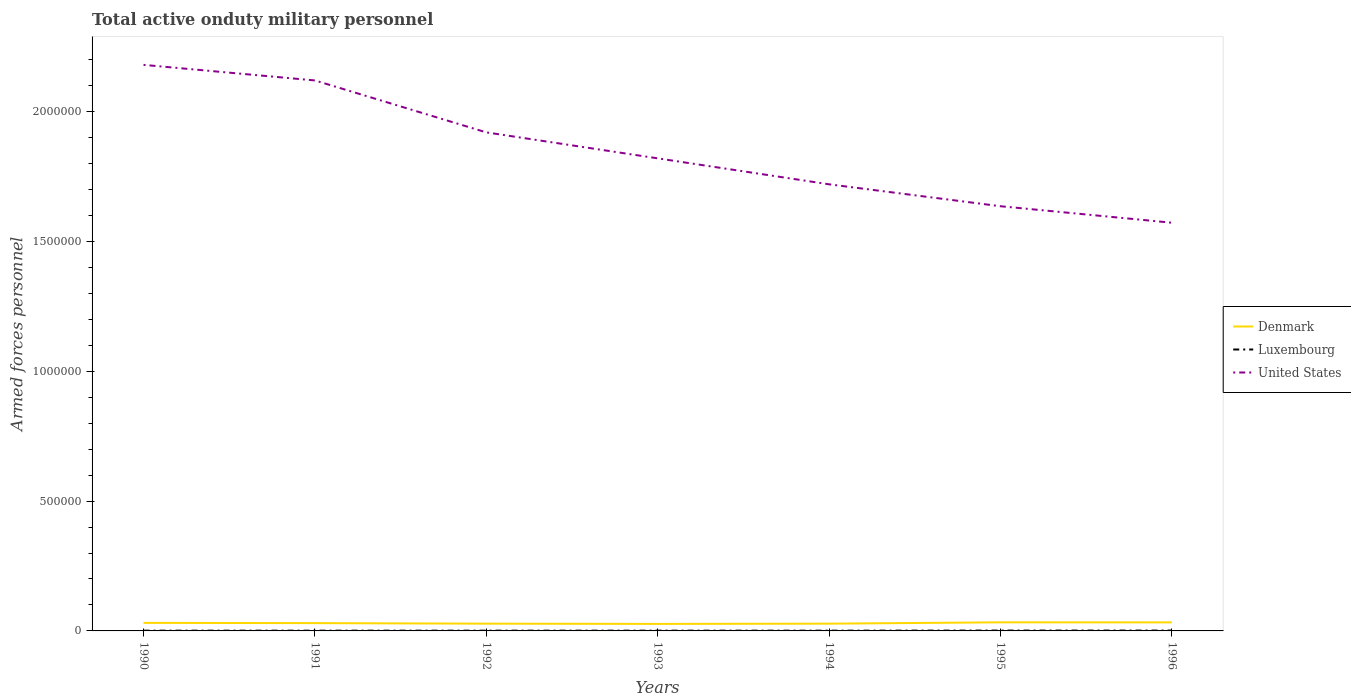Across all years, what is the maximum number of armed forces personnel in United States?
Your answer should be compact. 1.57e+06. What is the total number of armed forces personnel in United States in the graph?
Provide a short and direct response. 5.48e+05. What is the difference between the highest and the second highest number of armed forces personnel in Denmark?
Offer a very short reply. 6100. What is the difference between the highest and the lowest number of armed forces personnel in Luxembourg?
Make the answer very short. 2. Is the number of armed forces personnel in Denmark strictly greater than the number of armed forces personnel in United States over the years?
Keep it short and to the point. Yes. How many lines are there?
Offer a very short reply. 3. How many years are there in the graph?
Give a very brief answer. 7. What is the difference between two consecutive major ticks on the Y-axis?
Offer a very short reply. 5.00e+05. Are the values on the major ticks of Y-axis written in scientific E-notation?
Your answer should be compact. No. Does the graph contain any zero values?
Keep it short and to the point. No. How are the legend labels stacked?
Offer a terse response. Vertical. What is the title of the graph?
Your answer should be very brief. Total active onduty military personnel. Does "Malta" appear as one of the legend labels in the graph?
Your answer should be very brief. No. What is the label or title of the X-axis?
Provide a short and direct response. Years. What is the label or title of the Y-axis?
Offer a terse response. Armed forces personnel. What is the Armed forces personnel in Denmark in 1990?
Your answer should be compact. 3.10e+04. What is the Armed forces personnel in United States in 1990?
Offer a very short reply. 2.18e+06. What is the Armed forces personnel in Luxembourg in 1991?
Offer a terse response. 1000. What is the Armed forces personnel in United States in 1991?
Give a very brief answer. 2.12e+06. What is the Armed forces personnel of Denmark in 1992?
Provide a short and direct response. 2.80e+04. What is the Armed forces personnel in United States in 1992?
Keep it short and to the point. 1.92e+06. What is the Armed forces personnel in Denmark in 1993?
Your response must be concise. 2.70e+04. What is the Armed forces personnel in Luxembourg in 1993?
Offer a terse response. 1000. What is the Armed forces personnel in United States in 1993?
Make the answer very short. 1.82e+06. What is the Armed forces personnel of Denmark in 1994?
Provide a short and direct response. 2.80e+04. What is the Armed forces personnel of Luxembourg in 1994?
Make the answer very short. 1000. What is the Armed forces personnel in United States in 1994?
Your answer should be compact. 1.72e+06. What is the Armed forces personnel of Denmark in 1995?
Provide a short and direct response. 3.31e+04. What is the Armed forces personnel in Luxembourg in 1995?
Make the answer very short. 1400. What is the Armed forces personnel of United States in 1995?
Your answer should be very brief. 1.64e+06. What is the Armed forces personnel in Denmark in 1996?
Provide a succinct answer. 3.29e+04. What is the Armed forces personnel in Luxembourg in 1996?
Give a very brief answer. 1400. What is the Armed forces personnel in United States in 1996?
Make the answer very short. 1.57e+06. Across all years, what is the maximum Armed forces personnel of Denmark?
Offer a very short reply. 3.31e+04. Across all years, what is the maximum Armed forces personnel in Luxembourg?
Your answer should be compact. 1400. Across all years, what is the maximum Armed forces personnel of United States?
Provide a short and direct response. 2.18e+06. Across all years, what is the minimum Armed forces personnel in Denmark?
Your answer should be very brief. 2.70e+04. Across all years, what is the minimum Armed forces personnel of United States?
Provide a short and direct response. 1.57e+06. What is the total Armed forces personnel in Denmark in the graph?
Keep it short and to the point. 2.10e+05. What is the total Armed forces personnel of Luxembourg in the graph?
Ensure brevity in your answer.  7800. What is the total Armed forces personnel in United States in the graph?
Your answer should be compact. 1.30e+07. What is the difference between the Armed forces personnel in Denmark in 1990 and that in 1991?
Give a very brief answer. 1000. What is the difference between the Armed forces personnel of Luxembourg in 1990 and that in 1991?
Offer a very short reply. 0. What is the difference between the Armed forces personnel in United States in 1990 and that in 1991?
Give a very brief answer. 6.00e+04. What is the difference between the Armed forces personnel of Denmark in 1990 and that in 1992?
Keep it short and to the point. 3000. What is the difference between the Armed forces personnel in Luxembourg in 1990 and that in 1992?
Make the answer very short. 0. What is the difference between the Armed forces personnel of United States in 1990 and that in 1992?
Give a very brief answer. 2.60e+05. What is the difference between the Armed forces personnel of Denmark in 1990 and that in 1993?
Ensure brevity in your answer.  4000. What is the difference between the Armed forces personnel of Luxembourg in 1990 and that in 1993?
Provide a short and direct response. 0. What is the difference between the Armed forces personnel in United States in 1990 and that in 1993?
Give a very brief answer. 3.60e+05. What is the difference between the Armed forces personnel in Denmark in 1990 and that in 1994?
Ensure brevity in your answer.  3000. What is the difference between the Armed forces personnel of Denmark in 1990 and that in 1995?
Ensure brevity in your answer.  -2100. What is the difference between the Armed forces personnel of Luxembourg in 1990 and that in 1995?
Provide a succinct answer. -400. What is the difference between the Armed forces personnel of United States in 1990 and that in 1995?
Provide a succinct answer. 5.44e+05. What is the difference between the Armed forces personnel in Denmark in 1990 and that in 1996?
Offer a terse response. -1900. What is the difference between the Armed forces personnel of Luxembourg in 1990 and that in 1996?
Offer a very short reply. -400. What is the difference between the Armed forces personnel of United States in 1990 and that in 1996?
Your answer should be compact. 6.08e+05. What is the difference between the Armed forces personnel in Denmark in 1991 and that in 1992?
Your answer should be compact. 2000. What is the difference between the Armed forces personnel in United States in 1991 and that in 1992?
Offer a terse response. 2.00e+05. What is the difference between the Armed forces personnel of Denmark in 1991 and that in 1993?
Your answer should be compact. 3000. What is the difference between the Armed forces personnel in United States in 1991 and that in 1993?
Offer a terse response. 3.00e+05. What is the difference between the Armed forces personnel in Denmark in 1991 and that in 1994?
Give a very brief answer. 2000. What is the difference between the Armed forces personnel of Luxembourg in 1991 and that in 1994?
Provide a succinct answer. 0. What is the difference between the Armed forces personnel in United States in 1991 and that in 1994?
Keep it short and to the point. 4.00e+05. What is the difference between the Armed forces personnel in Denmark in 1991 and that in 1995?
Keep it short and to the point. -3100. What is the difference between the Armed forces personnel in Luxembourg in 1991 and that in 1995?
Keep it short and to the point. -400. What is the difference between the Armed forces personnel of United States in 1991 and that in 1995?
Provide a succinct answer. 4.84e+05. What is the difference between the Armed forces personnel in Denmark in 1991 and that in 1996?
Ensure brevity in your answer.  -2900. What is the difference between the Armed forces personnel of Luxembourg in 1991 and that in 1996?
Keep it short and to the point. -400. What is the difference between the Armed forces personnel in United States in 1991 and that in 1996?
Keep it short and to the point. 5.48e+05. What is the difference between the Armed forces personnel in Luxembourg in 1992 and that in 1993?
Your answer should be compact. 0. What is the difference between the Armed forces personnel in United States in 1992 and that in 1993?
Offer a very short reply. 1.00e+05. What is the difference between the Armed forces personnel of Denmark in 1992 and that in 1994?
Your answer should be very brief. 0. What is the difference between the Armed forces personnel of United States in 1992 and that in 1994?
Your answer should be very brief. 2.00e+05. What is the difference between the Armed forces personnel in Denmark in 1992 and that in 1995?
Make the answer very short. -5100. What is the difference between the Armed forces personnel of Luxembourg in 1992 and that in 1995?
Make the answer very short. -400. What is the difference between the Armed forces personnel of United States in 1992 and that in 1995?
Your response must be concise. 2.84e+05. What is the difference between the Armed forces personnel in Denmark in 1992 and that in 1996?
Make the answer very short. -4900. What is the difference between the Armed forces personnel in Luxembourg in 1992 and that in 1996?
Your answer should be compact. -400. What is the difference between the Armed forces personnel of United States in 1992 and that in 1996?
Make the answer very short. 3.48e+05. What is the difference between the Armed forces personnel in Denmark in 1993 and that in 1994?
Offer a terse response. -1000. What is the difference between the Armed forces personnel of Luxembourg in 1993 and that in 1994?
Provide a succinct answer. 0. What is the difference between the Armed forces personnel of Denmark in 1993 and that in 1995?
Ensure brevity in your answer.  -6100. What is the difference between the Armed forces personnel in Luxembourg in 1993 and that in 1995?
Offer a very short reply. -400. What is the difference between the Armed forces personnel in United States in 1993 and that in 1995?
Your response must be concise. 1.84e+05. What is the difference between the Armed forces personnel in Denmark in 1993 and that in 1996?
Provide a succinct answer. -5900. What is the difference between the Armed forces personnel of Luxembourg in 1993 and that in 1996?
Your response must be concise. -400. What is the difference between the Armed forces personnel of United States in 1993 and that in 1996?
Provide a short and direct response. 2.48e+05. What is the difference between the Armed forces personnel of Denmark in 1994 and that in 1995?
Provide a succinct answer. -5100. What is the difference between the Armed forces personnel of Luxembourg in 1994 and that in 1995?
Offer a terse response. -400. What is the difference between the Armed forces personnel of United States in 1994 and that in 1995?
Offer a very short reply. 8.44e+04. What is the difference between the Armed forces personnel in Denmark in 1994 and that in 1996?
Give a very brief answer. -4900. What is the difference between the Armed forces personnel in Luxembourg in 1994 and that in 1996?
Your answer should be very brief. -400. What is the difference between the Armed forces personnel of United States in 1994 and that in 1996?
Your answer should be compact. 1.48e+05. What is the difference between the Armed forces personnel in United States in 1995 and that in 1996?
Make the answer very short. 6.35e+04. What is the difference between the Armed forces personnel in Denmark in 1990 and the Armed forces personnel in Luxembourg in 1991?
Keep it short and to the point. 3.00e+04. What is the difference between the Armed forces personnel in Denmark in 1990 and the Armed forces personnel in United States in 1991?
Keep it short and to the point. -2.09e+06. What is the difference between the Armed forces personnel in Luxembourg in 1990 and the Armed forces personnel in United States in 1991?
Ensure brevity in your answer.  -2.12e+06. What is the difference between the Armed forces personnel in Denmark in 1990 and the Armed forces personnel in United States in 1992?
Make the answer very short. -1.89e+06. What is the difference between the Armed forces personnel in Luxembourg in 1990 and the Armed forces personnel in United States in 1992?
Offer a terse response. -1.92e+06. What is the difference between the Armed forces personnel of Denmark in 1990 and the Armed forces personnel of United States in 1993?
Ensure brevity in your answer.  -1.79e+06. What is the difference between the Armed forces personnel in Luxembourg in 1990 and the Armed forces personnel in United States in 1993?
Keep it short and to the point. -1.82e+06. What is the difference between the Armed forces personnel of Denmark in 1990 and the Armed forces personnel of Luxembourg in 1994?
Your response must be concise. 3.00e+04. What is the difference between the Armed forces personnel of Denmark in 1990 and the Armed forces personnel of United States in 1994?
Your answer should be compact. -1.69e+06. What is the difference between the Armed forces personnel of Luxembourg in 1990 and the Armed forces personnel of United States in 1994?
Give a very brief answer. -1.72e+06. What is the difference between the Armed forces personnel in Denmark in 1990 and the Armed forces personnel in Luxembourg in 1995?
Ensure brevity in your answer.  2.96e+04. What is the difference between the Armed forces personnel in Denmark in 1990 and the Armed forces personnel in United States in 1995?
Your response must be concise. -1.60e+06. What is the difference between the Armed forces personnel of Luxembourg in 1990 and the Armed forces personnel of United States in 1995?
Your response must be concise. -1.63e+06. What is the difference between the Armed forces personnel of Denmark in 1990 and the Armed forces personnel of Luxembourg in 1996?
Ensure brevity in your answer.  2.96e+04. What is the difference between the Armed forces personnel of Denmark in 1990 and the Armed forces personnel of United States in 1996?
Your answer should be very brief. -1.54e+06. What is the difference between the Armed forces personnel of Luxembourg in 1990 and the Armed forces personnel of United States in 1996?
Provide a succinct answer. -1.57e+06. What is the difference between the Armed forces personnel of Denmark in 1991 and the Armed forces personnel of Luxembourg in 1992?
Offer a very short reply. 2.90e+04. What is the difference between the Armed forces personnel of Denmark in 1991 and the Armed forces personnel of United States in 1992?
Provide a short and direct response. -1.89e+06. What is the difference between the Armed forces personnel of Luxembourg in 1991 and the Armed forces personnel of United States in 1992?
Keep it short and to the point. -1.92e+06. What is the difference between the Armed forces personnel of Denmark in 1991 and the Armed forces personnel of Luxembourg in 1993?
Make the answer very short. 2.90e+04. What is the difference between the Armed forces personnel in Denmark in 1991 and the Armed forces personnel in United States in 1993?
Ensure brevity in your answer.  -1.79e+06. What is the difference between the Armed forces personnel of Luxembourg in 1991 and the Armed forces personnel of United States in 1993?
Your answer should be very brief. -1.82e+06. What is the difference between the Armed forces personnel of Denmark in 1991 and the Armed forces personnel of Luxembourg in 1994?
Offer a very short reply. 2.90e+04. What is the difference between the Armed forces personnel of Denmark in 1991 and the Armed forces personnel of United States in 1994?
Offer a terse response. -1.69e+06. What is the difference between the Armed forces personnel of Luxembourg in 1991 and the Armed forces personnel of United States in 1994?
Provide a short and direct response. -1.72e+06. What is the difference between the Armed forces personnel of Denmark in 1991 and the Armed forces personnel of Luxembourg in 1995?
Ensure brevity in your answer.  2.86e+04. What is the difference between the Armed forces personnel in Denmark in 1991 and the Armed forces personnel in United States in 1995?
Your answer should be very brief. -1.61e+06. What is the difference between the Armed forces personnel in Luxembourg in 1991 and the Armed forces personnel in United States in 1995?
Ensure brevity in your answer.  -1.63e+06. What is the difference between the Armed forces personnel in Denmark in 1991 and the Armed forces personnel in Luxembourg in 1996?
Offer a terse response. 2.86e+04. What is the difference between the Armed forces personnel of Denmark in 1991 and the Armed forces personnel of United States in 1996?
Your answer should be very brief. -1.54e+06. What is the difference between the Armed forces personnel of Luxembourg in 1991 and the Armed forces personnel of United States in 1996?
Provide a short and direct response. -1.57e+06. What is the difference between the Armed forces personnel in Denmark in 1992 and the Armed forces personnel in Luxembourg in 1993?
Offer a terse response. 2.70e+04. What is the difference between the Armed forces personnel of Denmark in 1992 and the Armed forces personnel of United States in 1993?
Keep it short and to the point. -1.79e+06. What is the difference between the Armed forces personnel of Luxembourg in 1992 and the Armed forces personnel of United States in 1993?
Make the answer very short. -1.82e+06. What is the difference between the Armed forces personnel in Denmark in 1992 and the Armed forces personnel in Luxembourg in 1994?
Your answer should be compact. 2.70e+04. What is the difference between the Armed forces personnel of Denmark in 1992 and the Armed forces personnel of United States in 1994?
Provide a short and direct response. -1.69e+06. What is the difference between the Armed forces personnel in Luxembourg in 1992 and the Armed forces personnel in United States in 1994?
Offer a very short reply. -1.72e+06. What is the difference between the Armed forces personnel in Denmark in 1992 and the Armed forces personnel in Luxembourg in 1995?
Offer a terse response. 2.66e+04. What is the difference between the Armed forces personnel of Denmark in 1992 and the Armed forces personnel of United States in 1995?
Your answer should be very brief. -1.61e+06. What is the difference between the Armed forces personnel of Luxembourg in 1992 and the Armed forces personnel of United States in 1995?
Provide a succinct answer. -1.63e+06. What is the difference between the Armed forces personnel of Denmark in 1992 and the Armed forces personnel of Luxembourg in 1996?
Your answer should be very brief. 2.66e+04. What is the difference between the Armed forces personnel of Denmark in 1992 and the Armed forces personnel of United States in 1996?
Provide a short and direct response. -1.54e+06. What is the difference between the Armed forces personnel in Luxembourg in 1992 and the Armed forces personnel in United States in 1996?
Keep it short and to the point. -1.57e+06. What is the difference between the Armed forces personnel of Denmark in 1993 and the Armed forces personnel of Luxembourg in 1994?
Offer a very short reply. 2.60e+04. What is the difference between the Armed forces personnel of Denmark in 1993 and the Armed forces personnel of United States in 1994?
Provide a succinct answer. -1.69e+06. What is the difference between the Armed forces personnel in Luxembourg in 1993 and the Armed forces personnel in United States in 1994?
Make the answer very short. -1.72e+06. What is the difference between the Armed forces personnel in Denmark in 1993 and the Armed forces personnel in Luxembourg in 1995?
Give a very brief answer. 2.56e+04. What is the difference between the Armed forces personnel in Denmark in 1993 and the Armed forces personnel in United States in 1995?
Make the answer very short. -1.61e+06. What is the difference between the Armed forces personnel of Luxembourg in 1993 and the Armed forces personnel of United States in 1995?
Your answer should be compact. -1.63e+06. What is the difference between the Armed forces personnel of Denmark in 1993 and the Armed forces personnel of Luxembourg in 1996?
Make the answer very short. 2.56e+04. What is the difference between the Armed forces personnel in Denmark in 1993 and the Armed forces personnel in United States in 1996?
Your answer should be compact. -1.55e+06. What is the difference between the Armed forces personnel of Luxembourg in 1993 and the Armed forces personnel of United States in 1996?
Give a very brief answer. -1.57e+06. What is the difference between the Armed forces personnel in Denmark in 1994 and the Armed forces personnel in Luxembourg in 1995?
Provide a succinct answer. 2.66e+04. What is the difference between the Armed forces personnel of Denmark in 1994 and the Armed forces personnel of United States in 1995?
Provide a succinct answer. -1.61e+06. What is the difference between the Armed forces personnel in Luxembourg in 1994 and the Armed forces personnel in United States in 1995?
Keep it short and to the point. -1.63e+06. What is the difference between the Armed forces personnel in Denmark in 1994 and the Armed forces personnel in Luxembourg in 1996?
Offer a very short reply. 2.66e+04. What is the difference between the Armed forces personnel of Denmark in 1994 and the Armed forces personnel of United States in 1996?
Your answer should be very brief. -1.54e+06. What is the difference between the Armed forces personnel of Luxembourg in 1994 and the Armed forces personnel of United States in 1996?
Provide a short and direct response. -1.57e+06. What is the difference between the Armed forces personnel of Denmark in 1995 and the Armed forces personnel of Luxembourg in 1996?
Provide a succinct answer. 3.17e+04. What is the difference between the Armed forces personnel in Denmark in 1995 and the Armed forces personnel in United States in 1996?
Give a very brief answer. -1.54e+06. What is the difference between the Armed forces personnel of Luxembourg in 1995 and the Armed forces personnel of United States in 1996?
Ensure brevity in your answer.  -1.57e+06. What is the average Armed forces personnel of Luxembourg per year?
Keep it short and to the point. 1114.29. What is the average Armed forces personnel in United States per year?
Provide a short and direct response. 1.85e+06. In the year 1990, what is the difference between the Armed forces personnel in Denmark and Armed forces personnel in United States?
Your answer should be very brief. -2.15e+06. In the year 1990, what is the difference between the Armed forces personnel in Luxembourg and Armed forces personnel in United States?
Provide a short and direct response. -2.18e+06. In the year 1991, what is the difference between the Armed forces personnel of Denmark and Armed forces personnel of Luxembourg?
Your answer should be compact. 2.90e+04. In the year 1991, what is the difference between the Armed forces personnel of Denmark and Armed forces personnel of United States?
Your answer should be compact. -2.09e+06. In the year 1991, what is the difference between the Armed forces personnel in Luxembourg and Armed forces personnel in United States?
Your answer should be compact. -2.12e+06. In the year 1992, what is the difference between the Armed forces personnel of Denmark and Armed forces personnel of Luxembourg?
Ensure brevity in your answer.  2.70e+04. In the year 1992, what is the difference between the Armed forces personnel of Denmark and Armed forces personnel of United States?
Make the answer very short. -1.89e+06. In the year 1992, what is the difference between the Armed forces personnel of Luxembourg and Armed forces personnel of United States?
Ensure brevity in your answer.  -1.92e+06. In the year 1993, what is the difference between the Armed forces personnel of Denmark and Armed forces personnel of Luxembourg?
Provide a succinct answer. 2.60e+04. In the year 1993, what is the difference between the Armed forces personnel in Denmark and Armed forces personnel in United States?
Your answer should be very brief. -1.79e+06. In the year 1993, what is the difference between the Armed forces personnel in Luxembourg and Armed forces personnel in United States?
Your answer should be compact. -1.82e+06. In the year 1994, what is the difference between the Armed forces personnel of Denmark and Armed forces personnel of Luxembourg?
Offer a terse response. 2.70e+04. In the year 1994, what is the difference between the Armed forces personnel in Denmark and Armed forces personnel in United States?
Give a very brief answer. -1.69e+06. In the year 1994, what is the difference between the Armed forces personnel in Luxembourg and Armed forces personnel in United States?
Make the answer very short. -1.72e+06. In the year 1995, what is the difference between the Armed forces personnel of Denmark and Armed forces personnel of Luxembourg?
Provide a succinct answer. 3.17e+04. In the year 1995, what is the difference between the Armed forces personnel in Denmark and Armed forces personnel in United States?
Ensure brevity in your answer.  -1.60e+06. In the year 1995, what is the difference between the Armed forces personnel in Luxembourg and Armed forces personnel in United States?
Your response must be concise. -1.63e+06. In the year 1996, what is the difference between the Armed forces personnel in Denmark and Armed forces personnel in Luxembourg?
Give a very brief answer. 3.15e+04. In the year 1996, what is the difference between the Armed forces personnel in Denmark and Armed forces personnel in United States?
Your answer should be compact. -1.54e+06. In the year 1996, what is the difference between the Armed forces personnel in Luxembourg and Armed forces personnel in United States?
Your response must be concise. -1.57e+06. What is the ratio of the Armed forces personnel of Luxembourg in 1990 to that in 1991?
Ensure brevity in your answer.  1. What is the ratio of the Armed forces personnel in United States in 1990 to that in 1991?
Provide a short and direct response. 1.03. What is the ratio of the Armed forces personnel of Denmark in 1990 to that in 1992?
Keep it short and to the point. 1.11. What is the ratio of the Armed forces personnel in United States in 1990 to that in 1992?
Make the answer very short. 1.14. What is the ratio of the Armed forces personnel of Denmark in 1990 to that in 1993?
Your answer should be very brief. 1.15. What is the ratio of the Armed forces personnel of Luxembourg in 1990 to that in 1993?
Your response must be concise. 1. What is the ratio of the Armed forces personnel of United States in 1990 to that in 1993?
Your response must be concise. 1.2. What is the ratio of the Armed forces personnel in Denmark in 1990 to that in 1994?
Make the answer very short. 1.11. What is the ratio of the Armed forces personnel in United States in 1990 to that in 1994?
Your answer should be compact. 1.27. What is the ratio of the Armed forces personnel of Denmark in 1990 to that in 1995?
Provide a short and direct response. 0.94. What is the ratio of the Armed forces personnel in Luxembourg in 1990 to that in 1995?
Offer a terse response. 0.71. What is the ratio of the Armed forces personnel in United States in 1990 to that in 1995?
Make the answer very short. 1.33. What is the ratio of the Armed forces personnel in Denmark in 1990 to that in 1996?
Provide a short and direct response. 0.94. What is the ratio of the Armed forces personnel of Luxembourg in 1990 to that in 1996?
Give a very brief answer. 0.71. What is the ratio of the Armed forces personnel of United States in 1990 to that in 1996?
Offer a very short reply. 1.39. What is the ratio of the Armed forces personnel in Denmark in 1991 to that in 1992?
Your response must be concise. 1.07. What is the ratio of the Armed forces personnel in Luxembourg in 1991 to that in 1992?
Give a very brief answer. 1. What is the ratio of the Armed forces personnel in United States in 1991 to that in 1992?
Offer a very short reply. 1.1. What is the ratio of the Armed forces personnel of Denmark in 1991 to that in 1993?
Give a very brief answer. 1.11. What is the ratio of the Armed forces personnel in Luxembourg in 1991 to that in 1993?
Your answer should be very brief. 1. What is the ratio of the Armed forces personnel in United States in 1991 to that in 1993?
Provide a succinct answer. 1.16. What is the ratio of the Armed forces personnel in Denmark in 1991 to that in 1994?
Offer a terse response. 1.07. What is the ratio of the Armed forces personnel of United States in 1991 to that in 1994?
Offer a very short reply. 1.23. What is the ratio of the Armed forces personnel of Denmark in 1991 to that in 1995?
Offer a terse response. 0.91. What is the ratio of the Armed forces personnel of United States in 1991 to that in 1995?
Offer a very short reply. 1.3. What is the ratio of the Armed forces personnel of Denmark in 1991 to that in 1996?
Offer a terse response. 0.91. What is the ratio of the Armed forces personnel of Luxembourg in 1991 to that in 1996?
Provide a short and direct response. 0.71. What is the ratio of the Armed forces personnel in United States in 1991 to that in 1996?
Provide a short and direct response. 1.35. What is the ratio of the Armed forces personnel in United States in 1992 to that in 1993?
Give a very brief answer. 1.05. What is the ratio of the Armed forces personnel in United States in 1992 to that in 1994?
Your answer should be very brief. 1.12. What is the ratio of the Armed forces personnel in Denmark in 1992 to that in 1995?
Ensure brevity in your answer.  0.85. What is the ratio of the Armed forces personnel of Luxembourg in 1992 to that in 1995?
Your answer should be very brief. 0.71. What is the ratio of the Armed forces personnel of United States in 1992 to that in 1995?
Offer a terse response. 1.17. What is the ratio of the Armed forces personnel of Denmark in 1992 to that in 1996?
Keep it short and to the point. 0.85. What is the ratio of the Armed forces personnel in Luxembourg in 1992 to that in 1996?
Provide a succinct answer. 0.71. What is the ratio of the Armed forces personnel in United States in 1992 to that in 1996?
Make the answer very short. 1.22. What is the ratio of the Armed forces personnel of Denmark in 1993 to that in 1994?
Keep it short and to the point. 0.96. What is the ratio of the Armed forces personnel in Luxembourg in 1993 to that in 1994?
Provide a succinct answer. 1. What is the ratio of the Armed forces personnel in United States in 1993 to that in 1994?
Provide a short and direct response. 1.06. What is the ratio of the Armed forces personnel in Denmark in 1993 to that in 1995?
Your response must be concise. 0.82. What is the ratio of the Armed forces personnel in Luxembourg in 1993 to that in 1995?
Keep it short and to the point. 0.71. What is the ratio of the Armed forces personnel of United States in 1993 to that in 1995?
Your response must be concise. 1.11. What is the ratio of the Armed forces personnel in Denmark in 1993 to that in 1996?
Your response must be concise. 0.82. What is the ratio of the Armed forces personnel of Luxembourg in 1993 to that in 1996?
Make the answer very short. 0.71. What is the ratio of the Armed forces personnel of United States in 1993 to that in 1996?
Provide a succinct answer. 1.16. What is the ratio of the Armed forces personnel in Denmark in 1994 to that in 1995?
Your answer should be very brief. 0.85. What is the ratio of the Armed forces personnel in United States in 1994 to that in 1995?
Offer a terse response. 1.05. What is the ratio of the Armed forces personnel in Denmark in 1994 to that in 1996?
Your response must be concise. 0.85. What is the ratio of the Armed forces personnel in Luxembourg in 1994 to that in 1996?
Give a very brief answer. 0.71. What is the ratio of the Armed forces personnel in United States in 1994 to that in 1996?
Ensure brevity in your answer.  1.09. What is the ratio of the Armed forces personnel in Luxembourg in 1995 to that in 1996?
Ensure brevity in your answer.  1. What is the ratio of the Armed forces personnel of United States in 1995 to that in 1996?
Your answer should be compact. 1.04. What is the difference between the highest and the second highest Armed forces personnel in Denmark?
Ensure brevity in your answer.  200. What is the difference between the highest and the second highest Armed forces personnel in United States?
Give a very brief answer. 6.00e+04. What is the difference between the highest and the lowest Armed forces personnel in Denmark?
Your answer should be very brief. 6100. What is the difference between the highest and the lowest Armed forces personnel in Luxembourg?
Keep it short and to the point. 400. What is the difference between the highest and the lowest Armed forces personnel in United States?
Your response must be concise. 6.08e+05. 